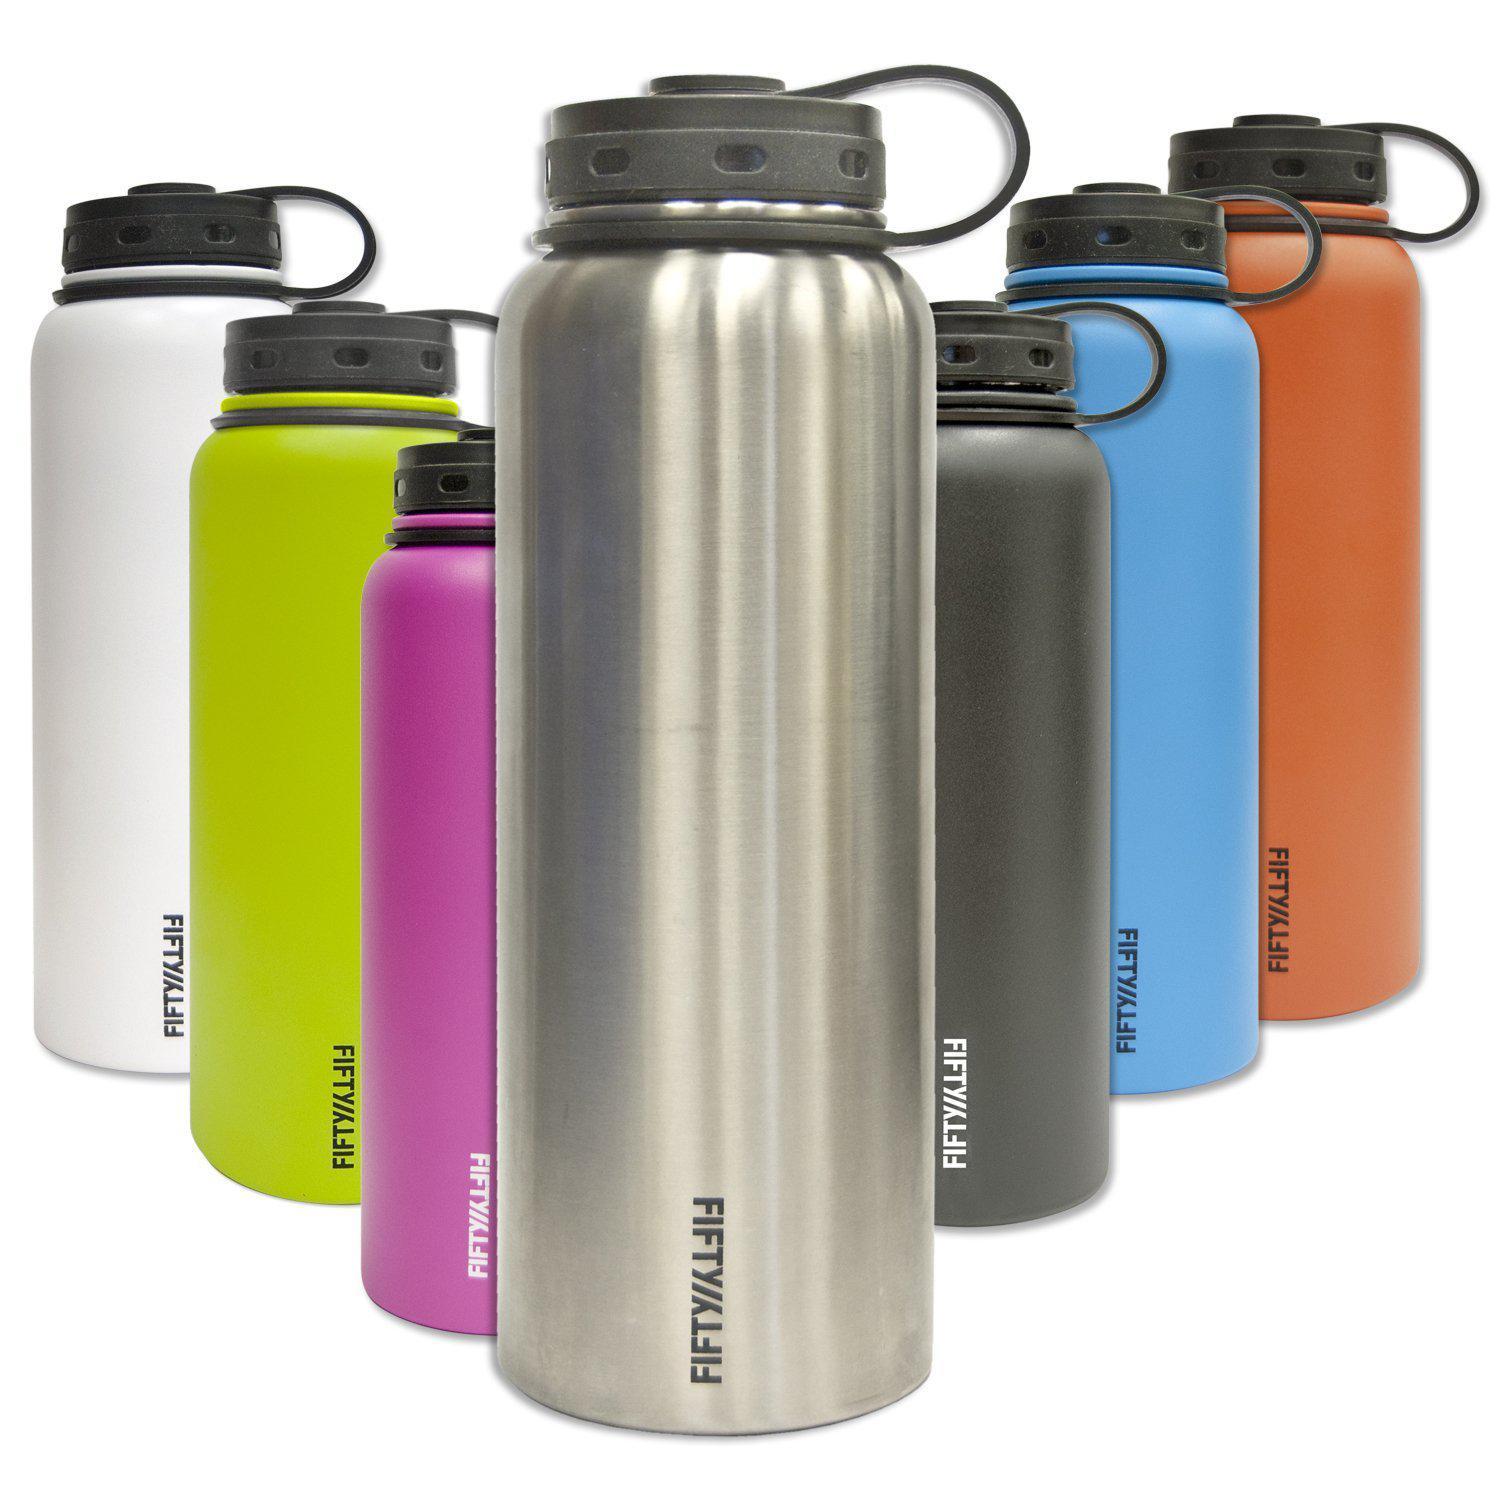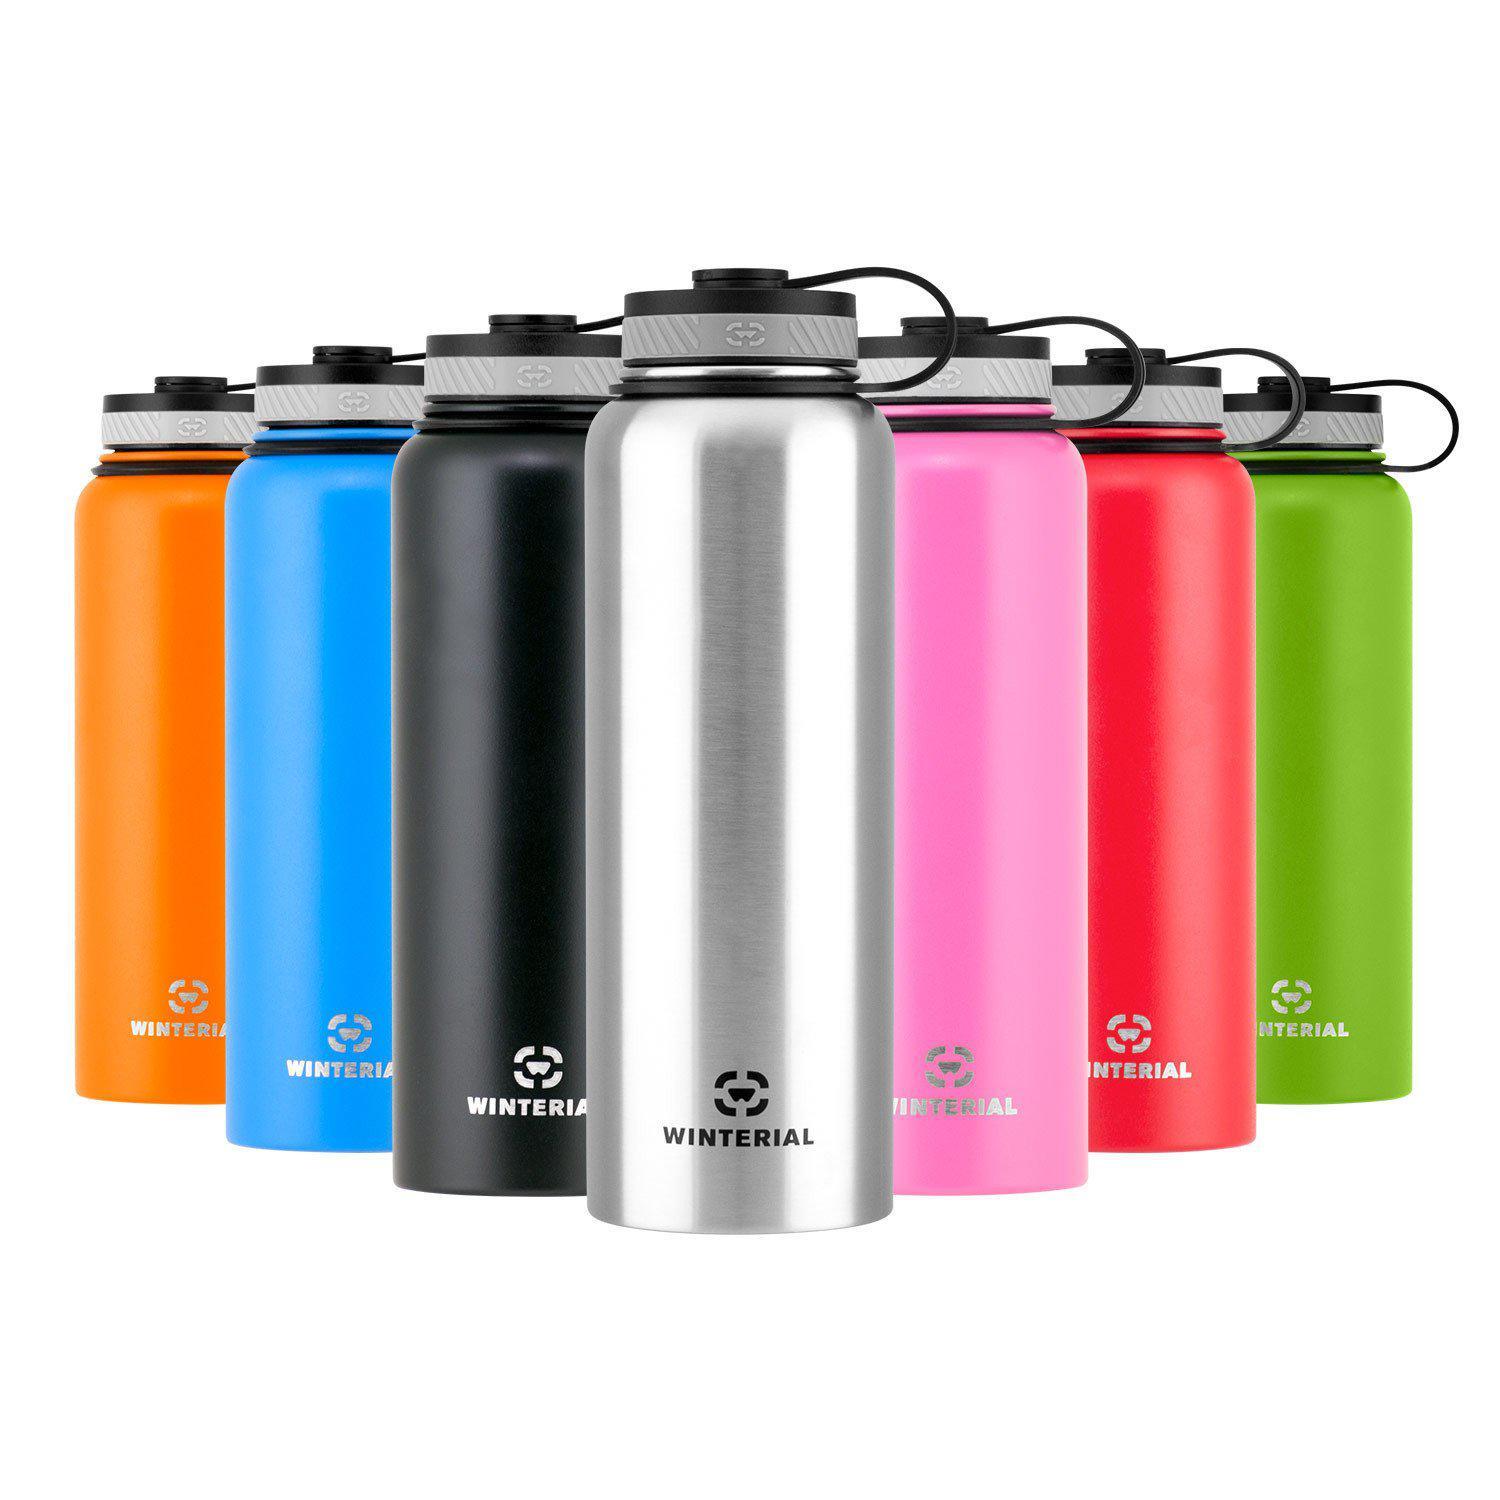The first image is the image on the left, the second image is the image on the right. Evaluate the accuracy of this statement regarding the images: "The left hand image contains a solo water bottle, while the left hand image contains a row or varying colored water bottles.". Is it true? Answer yes or no. No. The first image is the image on the left, the second image is the image on the right. Considering the images on both sides, is "The bottle in the left image that is closest to the left edge is chrome." valid? Answer yes or no. No. 